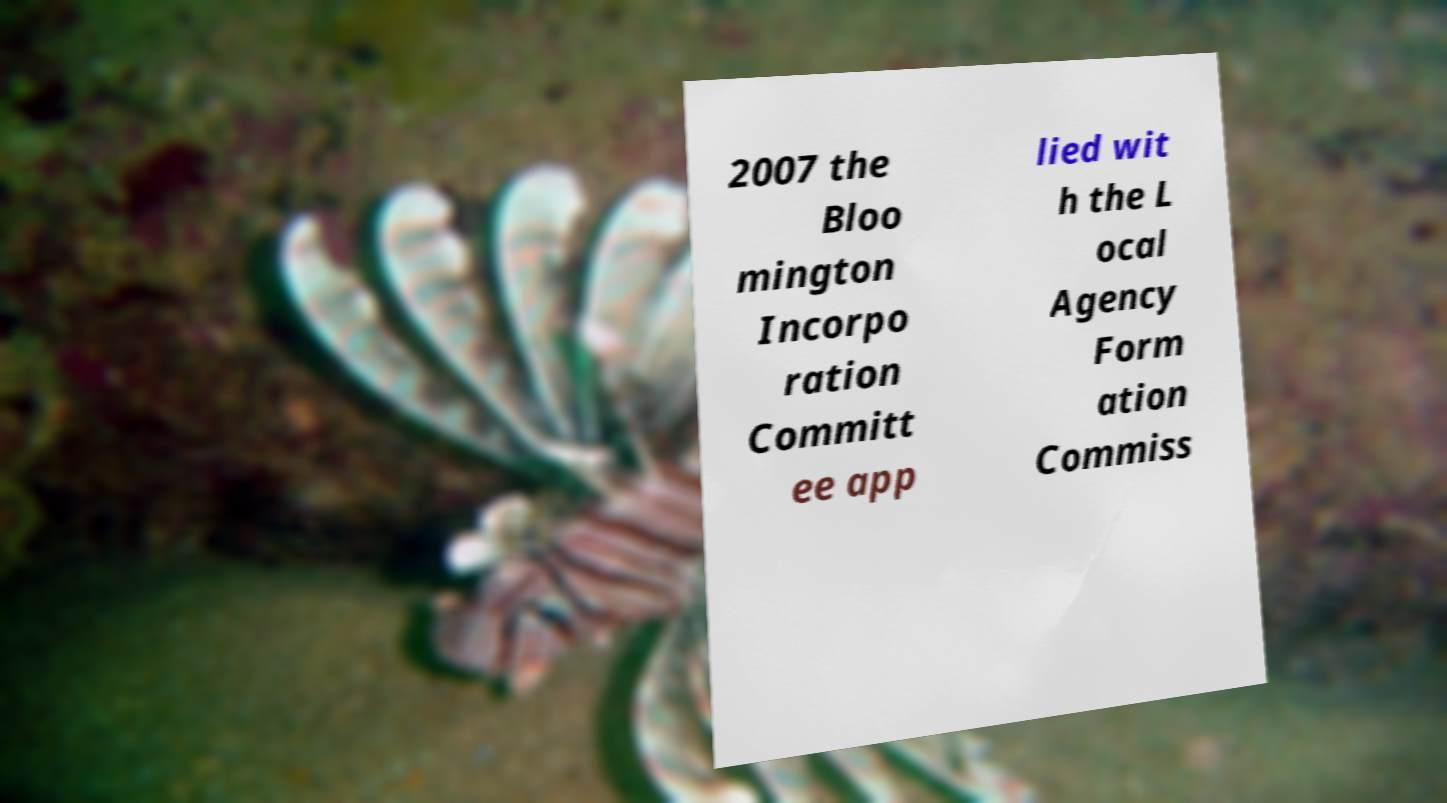Could you extract and type out the text from this image? 2007 the Bloo mington Incorpo ration Committ ee app lied wit h the L ocal Agency Form ation Commiss 